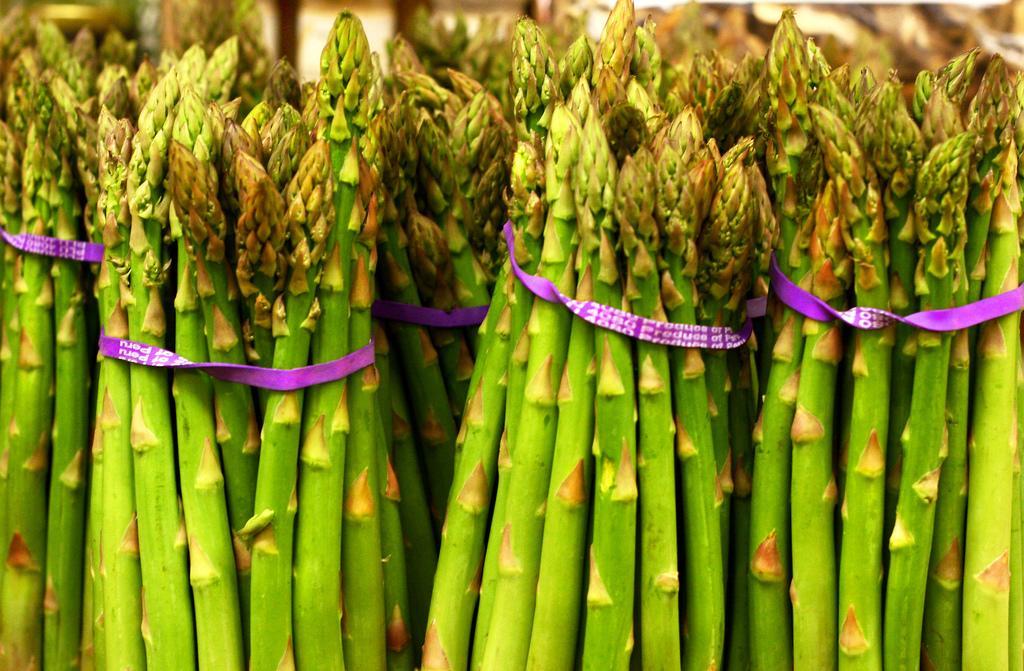How would you summarize this image in a sentence or two? In this image we can see bunches of asparagus. 